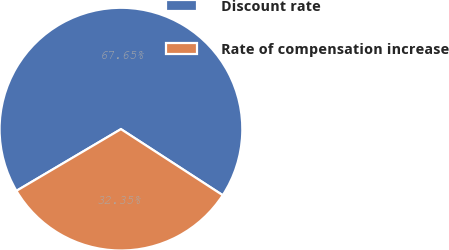Convert chart. <chart><loc_0><loc_0><loc_500><loc_500><pie_chart><fcel>Discount rate<fcel>Rate of compensation increase<nl><fcel>67.65%<fcel>32.35%<nl></chart> 